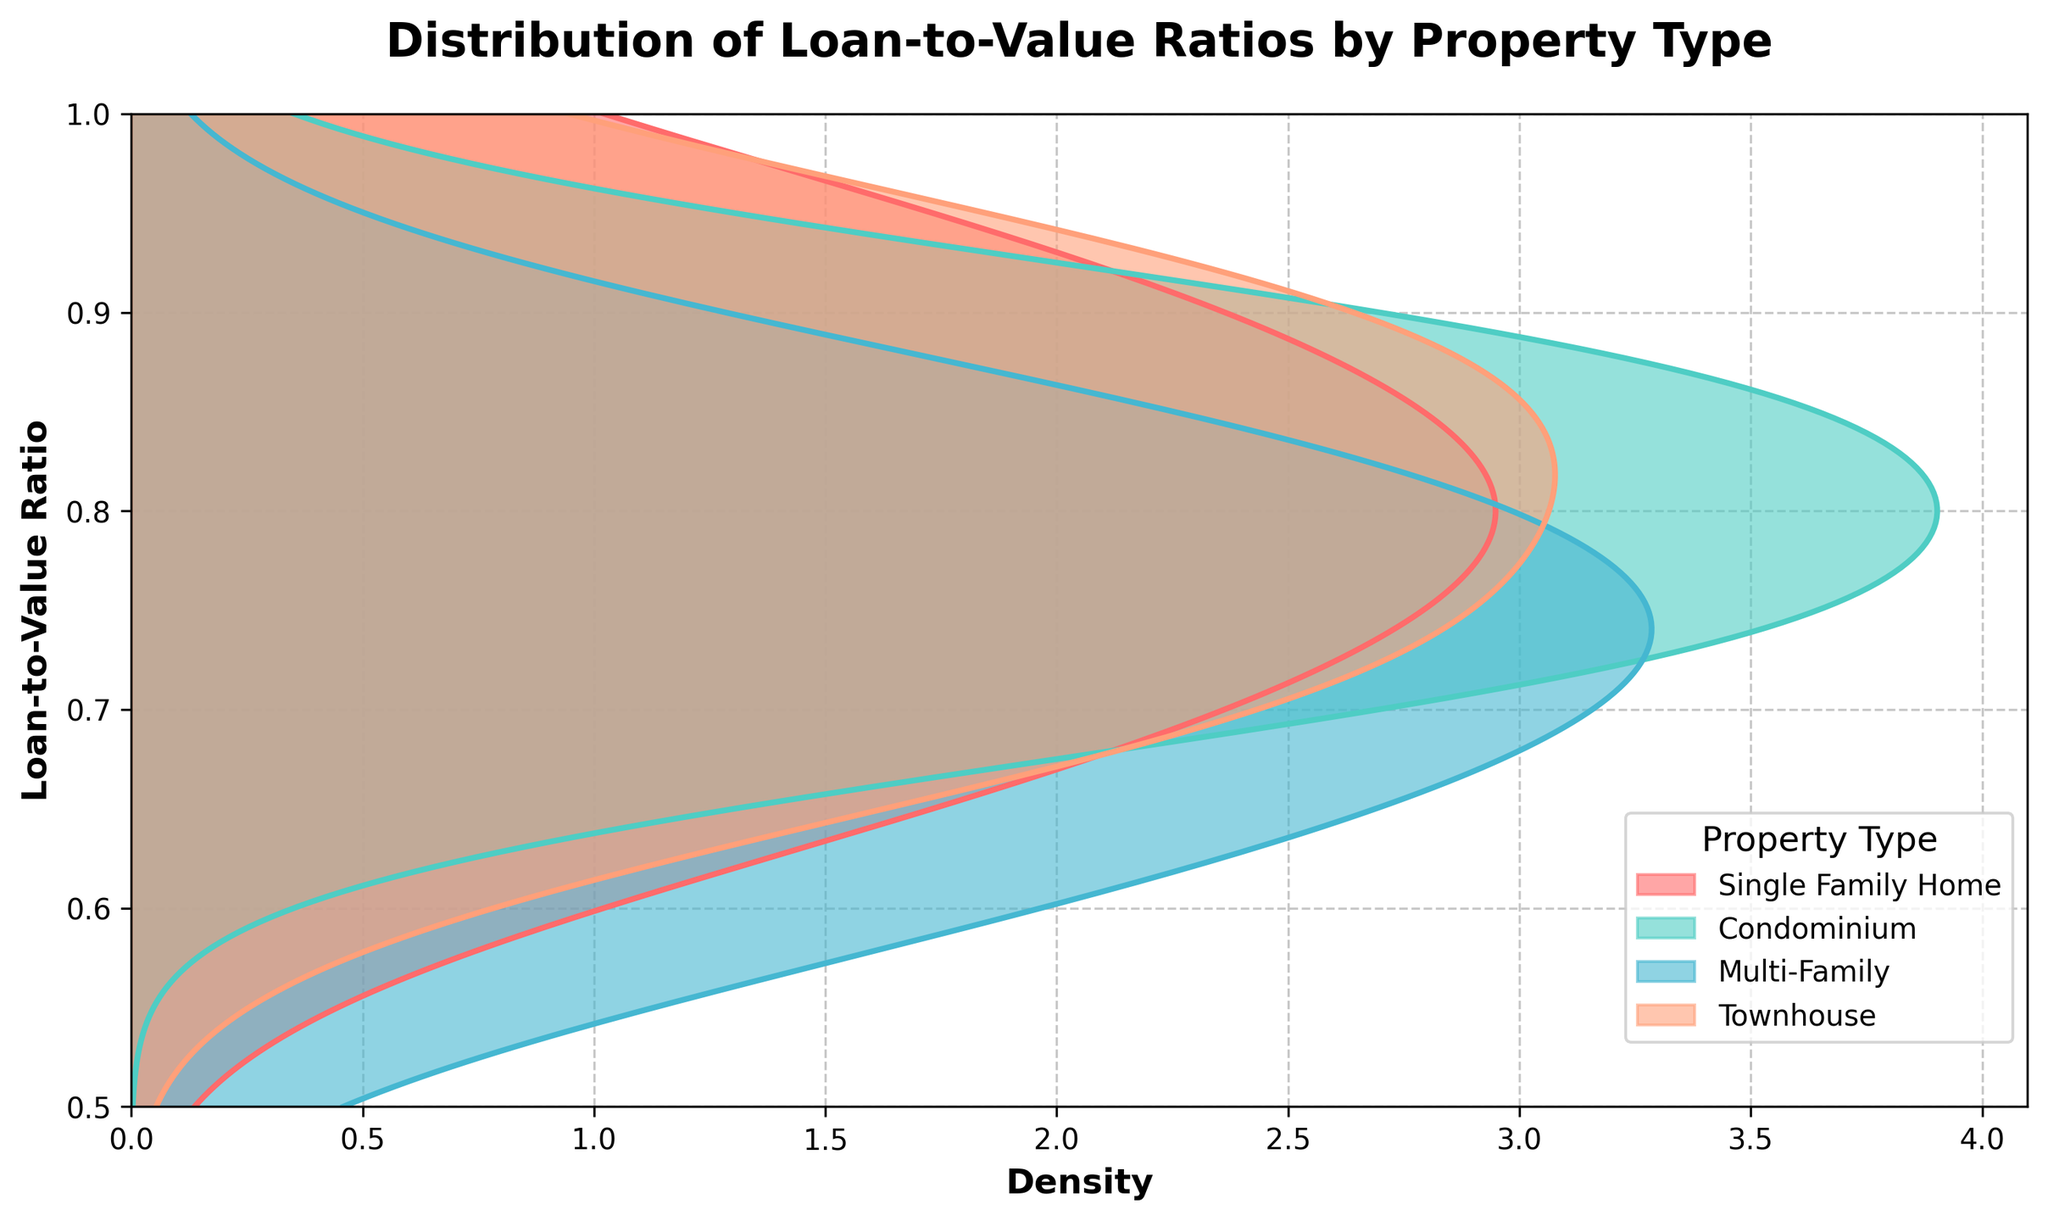What is the title of the plot? The title is located at the top of the figure and describes what the plot is about. It is written in bold and larger font than the other text.
Answer: Distribution of Loan-to-Value Ratios by Property Type Which axis represents the loan-to-value ratio? The y-axis represents the loan-to-value ratio as shown by the label "Loan-to-Value Ratio" on the vertical axis.
Answer: y-axis How many property types are shown in the plot? The legend on the plot indicates the number of different property types. Each property type is represented by a different color.
Answer: Four Which property type has the loan-to-value ratio distribution that extends closest to 1? By examining the density plots, observe which color curve comes nearest to the top boundary of the plot, which is marked as 1.
Answer: Townhouse What property type appears to have the widest distribution in loan-to-value ratios? The property type with the widest spread will have a density plot that spans a larger range on the y-axis compared to others.
Answer: Single Family Home Comparing Single Family Home and Multi-Family, which property type has a higher concentration of lower loan-to-value ratios? Look at the density curves for both property types and see which one has a higher peak towards the lower end of the y-axis.
Answer: Multi-Family Which property type has the least density variation throughout the loan-to-value range? A property type with minimal density variation will have a more uniform, less fluctuating density curve.
Answer: Condominium What is the predominant loan-to-value ratio range for Townhouses? Identify the y-axis range where the density curve for Townhouses has the highest peaks and appears to be the most elevated.
Answer: 0.8 to 0.9 Which property type appears to have the highest loan-to-value ratio? Observe the maximum point on the density curve for each property type to see which type's curve reaches the highest value on the y-axis.
Answer: Townhouse What can you infer about the risk profile of loans for Multi-Family properties based on their loan-to-value distribution? A higher density of lower loan-to-value ratios suggests a lower risk profile, as the borrowers are putting more equity into the property. By looking at the curve for Multi-Family, you can see where it is most concentrated.
Answer: Lower risk profile 